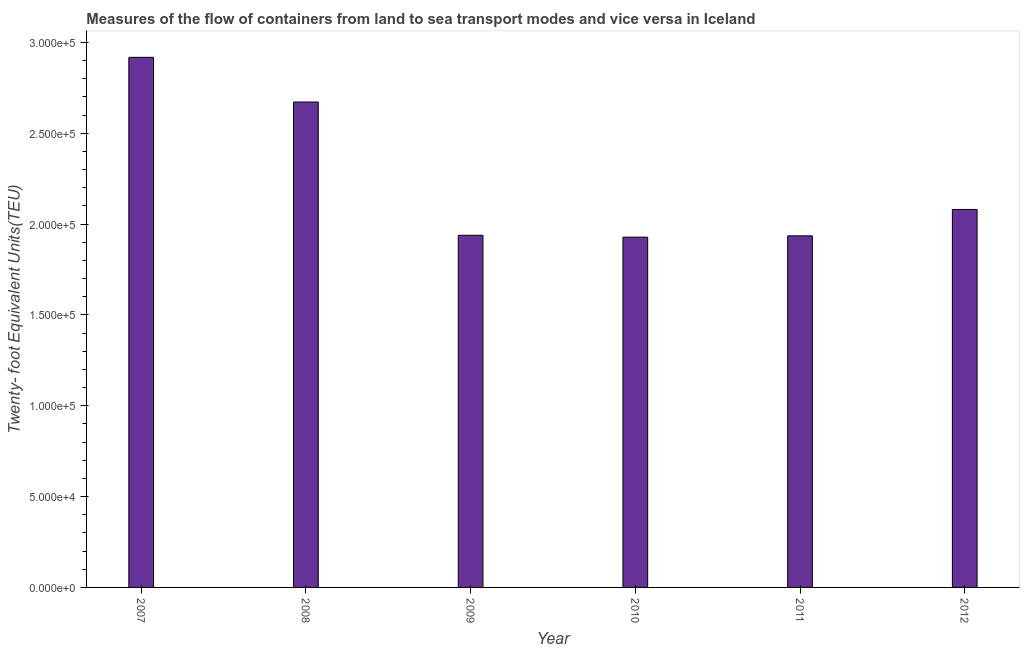Does the graph contain any zero values?
Give a very brief answer. No. What is the title of the graph?
Provide a short and direct response. Measures of the flow of containers from land to sea transport modes and vice versa in Iceland. What is the label or title of the Y-axis?
Make the answer very short. Twenty- foot Equivalent Units(TEU). What is the container port traffic in 2012?
Offer a very short reply. 2.08e+05. Across all years, what is the maximum container port traffic?
Your answer should be very brief. 2.92e+05. Across all years, what is the minimum container port traffic?
Provide a succinct answer. 1.93e+05. In which year was the container port traffic maximum?
Ensure brevity in your answer.  2007. In which year was the container port traffic minimum?
Keep it short and to the point. 2010. What is the sum of the container port traffic?
Ensure brevity in your answer.  1.35e+06. What is the difference between the container port traffic in 2007 and 2009?
Offer a terse response. 9.79e+04. What is the average container port traffic per year?
Your response must be concise. 2.25e+05. What is the median container port traffic?
Ensure brevity in your answer.  2.01e+05. In how many years, is the container port traffic greater than 60000 TEU?
Give a very brief answer. 6. Do a majority of the years between 2011 and 2007 (inclusive) have container port traffic greater than 90000 TEU?
Keep it short and to the point. Yes. What is the ratio of the container port traffic in 2009 to that in 2012?
Give a very brief answer. 0.93. What is the difference between the highest and the second highest container port traffic?
Give a very brief answer. 2.46e+04. What is the difference between the highest and the lowest container port traffic?
Give a very brief answer. 9.90e+04. In how many years, is the container port traffic greater than the average container port traffic taken over all years?
Offer a very short reply. 2. Are all the bars in the graph horizontal?
Provide a short and direct response. No. How many years are there in the graph?
Offer a terse response. 6. Are the values on the major ticks of Y-axis written in scientific E-notation?
Your answer should be compact. Yes. What is the Twenty- foot Equivalent Units(TEU) in 2007?
Your answer should be very brief. 2.92e+05. What is the Twenty- foot Equivalent Units(TEU) in 2008?
Provide a short and direct response. 2.67e+05. What is the Twenty- foot Equivalent Units(TEU) of 2009?
Provide a succinct answer. 1.94e+05. What is the Twenty- foot Equivalent Units(TEU) in 2010?
Keep it short and to the point. 1.93e+05. What is the Twenty- foot Equivalent Units(TEU) in 2011?
Give a very brief answer. 1.94e+05. What is the Twenty- foot Equivalent Units(TEU) in 2012?
Offer a very short reply. 2.08e+05. What is the difference between the Twenty- foot Equivalent Units(TEU) in 2007 and 2008?
Offer a terse response. 2.46e+04. What is the difference between the Twenty- foot Equivalent Units(TEU) in 2007 and 2009?
Offer a terse response. 9.79e+04. What is the difference between the Twenty- foot Equivalent Units(TEU) in 2007 and 2010?
Provide a succinct answer. 9.90e+04. What is the difference between the Twenty- foot Equivalent Units(TEU) in 2007 and 2011?
Keep it short and to the point. 9.82e+04. What is the difference between the Twenty- foot Equivalent Units(TEU) in 2007 and 2012?
Keep it short and to the point. 8.37e+04. What is the difference between the Twenty- foot Equivalent Units(TEU) in 2008 and 2009?
Your response must be concise. 7.33e+04. What is the difference between the Twenty- foot Equivalent Units(TEU) in 2008 and 2010?
Give a very brief answer. 7.44e+04. What is the difference between the Twenty- foot Equivalent Units(TEU) in 2008 and 2011?
Your response must be concise. 7.37e+04. What is the difference between the Twenty- foot Equivalent Units(TEU) in 2008 and 2012?
Offer a very short reply. 5.91e+04. What is the difference between the Twenty- foot Equivalent Units(TEU) in 2009 and 2010?
Provide a short and direct response. 1038. What is the difference between the Twenty- foot Equivalent Units(TEU) in 2009 and 2011?
Provide a short and direct response. 316. What is the difference between the Twenty- foot Equivalent Units(TEU) in 2009 and 2012?
Make the answer very short. -1.42e+04. What is the difference between the Twenty- foot Equivalent Units(TEU) in 2010 and 2011?
Offer a terse response. -722. What is the difference between the Twenty- foot Equivalent Units(TEU) in 2010 and 2012?
Keep it short and to the point. -1.52e+04. What is the difference between the Twenty- foot Equivalent Units(TEU) in 2011 and 2012?
Your answer should be compact. -1.45e+04. What is the ratio of the Twenty- foot Equivalent Units(TEU) in 2007 to that in 2008?
Offer a terse response. 1.09. What is the ratio of the Twenty- foot Equivalent Units(TEU) in 2007 to that in 2009?
Provide a short and direct response. 1.5. What is the ratio of the Twenty- foot Equivalent Units(TEU) in 2007 to that in 2010?
Keep it short and to the point. 1.51. What is the ratio of the Twenty- foot Equivalent Units(TEU) in 2007 to that in 2011?
Your response must be concise. 1.51. What is the ratio of the Twenty- foot Equivalent Units(TEU) in 2007 to that in 2012?
Your answer should be very brief. 1.4. What is the ratio of the Twenty- foot Equivalent Units(TEU) in 2008 to that in 2009?
Provide a succinct answer. 1.38. What is the ratio of the Twenty- foot Equivalent Units(TEU) in 2008 to that in 2010?
Provide a short and direct response. 1.39. What is the ratio of the Twenty- foot Equivalent Units(TEU) in 2008 to that in 2011?
Give a very brief answer. 1.38. What is the ratio of the Twenty- foot Equivalent Units(TEU) in 2008 to that in 2012?
Your answer should be compact. 1.28. What is the ratio of the Twenty- foot Equivalent Units(TEU) in 2009 to that in 2010?
Your answer should be very brief. 1. What is the ratio of the Twenty- foot Equivalent Units(TEU) in 2009 to that in 2011?
Provide a short and direct response. 1. What is the ratio of the Twenty- foot Equivalent Units(TEU) in 2009 to that in 2012?
Provide a short and direct response. 0.93. What is the ratio of the Twenty- foot Equivalent Units(TEU) in 2010 to that in 2012?
Your response must be concise. 0.93. What is the ratio of the Twenty- foot Equivalent Units(TEU) in 2011 to that in 2012?
Offer a very short reply. 0.93. 